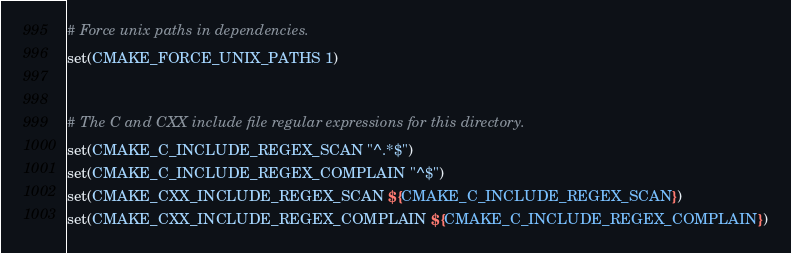Convert code to text. <code><loc_0><loc_0><loc_500><loc_500><_CMake_># Force unix paths in dependencies.
set(CMAKE_FORCE_UNIX_PATHS 1)


# The C and CXX include file regular expressions for this directory.
set(CMAKE_C_INCLUDE_REGEX_SCAN "^.*$")
set(CMAKE_C_INCLUDE_REGEX_COMPLAIN "^$")
set(CMAKE_CXX_INCLUDE_REGEX_SCAN ${CMAKE_C_INCLUDE_REGEX_SCAN})
set(CMAKE_CXX_INCLUDE_REGEX_COMPLAIN ${CMAKE_C_INCLUDE_REGEX_COMPLAIN})
</code> 